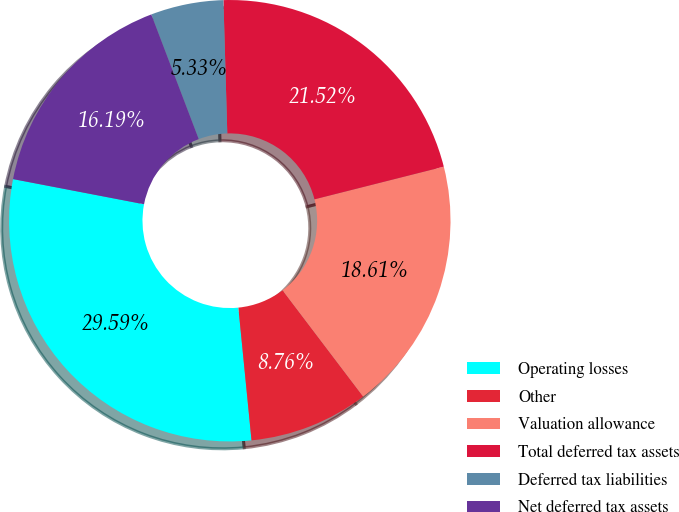Convert chart. <chart><loc_0><loc_0><loc_500><loc_500><pie_chart><fcel>Operating losses<fcel>Other<fcel>Valuation allowance<fcel>Total deferred tax assets<fcel>Deferred tax liabilities<fcel>Net deferred tax assets<nl><fcel>29.59%<fcel>8.76%<fcel>18.61%<fcel>21.52%<fcel>5.33%<fcel>16.19%<nl></chart> 